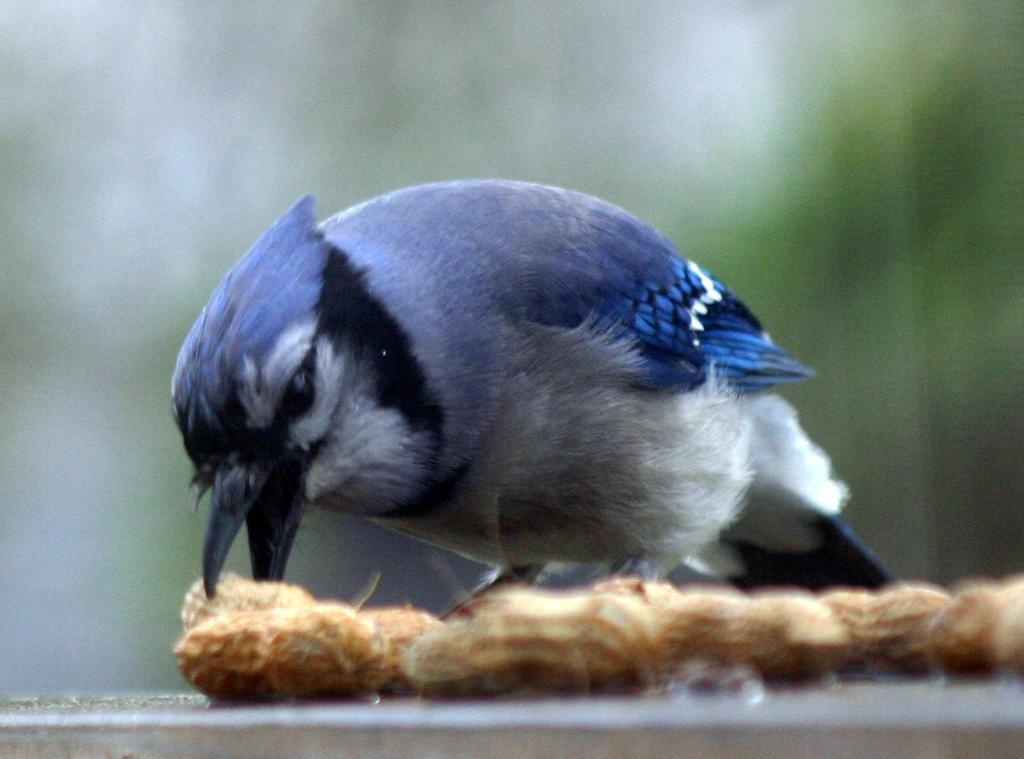What is located in the foreground of the picture? There are peanuts in the foreground of the picture. What can be seen on the concrete surface in the foreground? There is a bird on a concrete surface in the foreground. How would you describe the background of the image? The background of the image is blurred. What type of surprise is the bird planning to give on someone's birthday in the image? There is no indication of a surprise or birthday in the image; it simply features a bird on a concrete surface with peanuts in the foreground and a blurred background. 